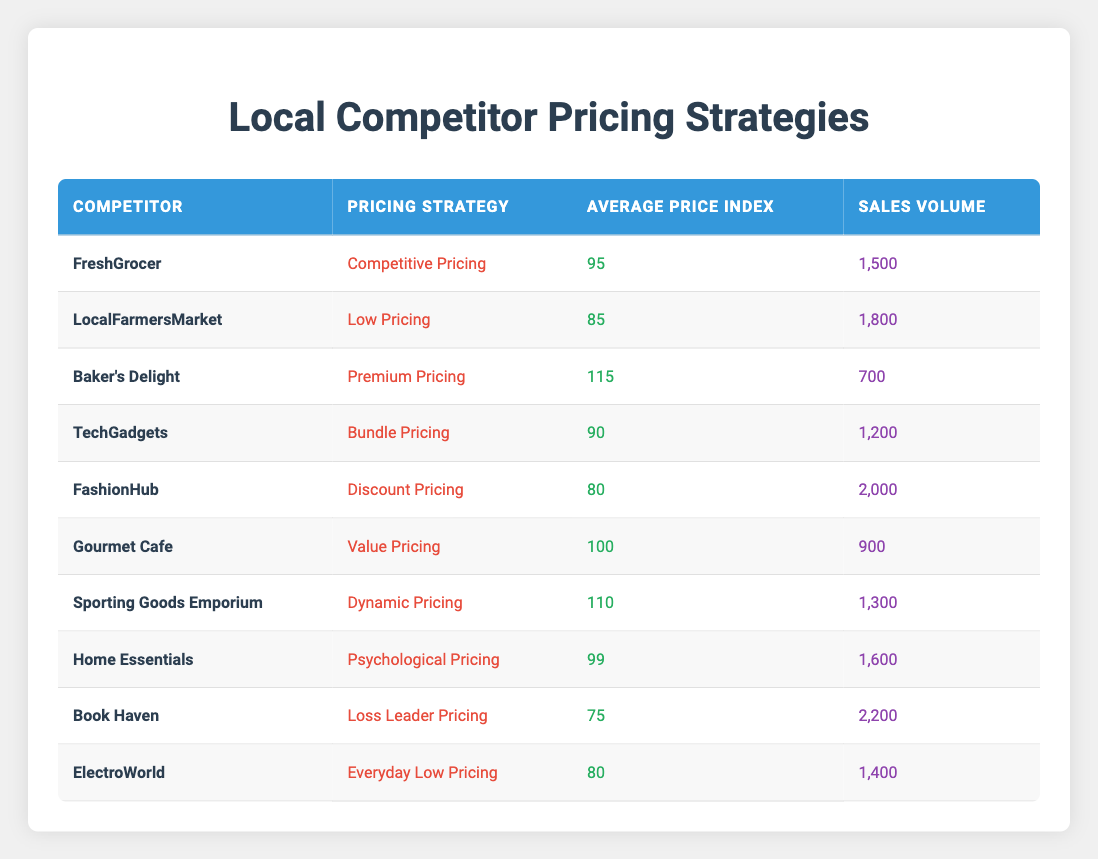What is the sales volume for FashionHub? The table lists FashionHub’s sales volume directly, which is indicated as 2000.
Answer: 2000 Which competitor employs dynamic pricing? The table shows that the competitor using dynamic pricing is Sporting Goods Emporium.
Answer: Sporting Goods Emporium What strategy does Book Haven use and what is its average price index? Referring to the table, Book Haven's pricing strategy is Loss Leader Pricing, and its average price index is 75.
Answer: Loss Leader Pricing, 75 What is the total sales volume of competitors using low pricing strategies? Only the LocalFarmersMarket uses a low pricing strategy with a sales volume of 1800. No other competitor has a specified low pricing strategy. Therefore, the total sales volume is 1800.
Answer: 1800 Is it true that the competitor with competitive pricing has a higher average price index than the one with discount pricing? Competitive pricing is employed by FreshGrocer with an average price index of 95, while discount pricing is used by FashionHub with an average price index of 80. Since 95 is greater than 80, the statement is true.
Answer: Yes What is the average sales volume of competitors with an average price index below 100? The competitors with an average price index below 100 are LocalFarmersMarket (1800), FashionHub (2000), and Book Haven (2200). Their total sales volume is 1800 + 2000 + 2200 = 6000. There are 3 competitors, so the average is 6000 / 3 = 2000.
Answer: 2000 Which pricing strategy corresponds to the lowest average price index and what is that index? The table shows that Book Haven uses Loss Leader Pricing, which has the lowest average price index of 75 compared to others.
Answer: Loss Leader Pricing, 75 Calculate the sales volume difference between the competitor with the highest and lowest sales volume. The competitor with the highest sales volume is Book Haven with 2200, and the lowest is Baker's Delight with 700. The difference is calculated as 2200 - 700 = 1500.
Answer: 1500 Which competitor has the highest sales volume and what pricing strategy do they use? From the table, Book Haven has the highest sales volume of 2200, and it employs Loss Leader Pricing.
Answer: Book Haven, Loss Leader Pricing 